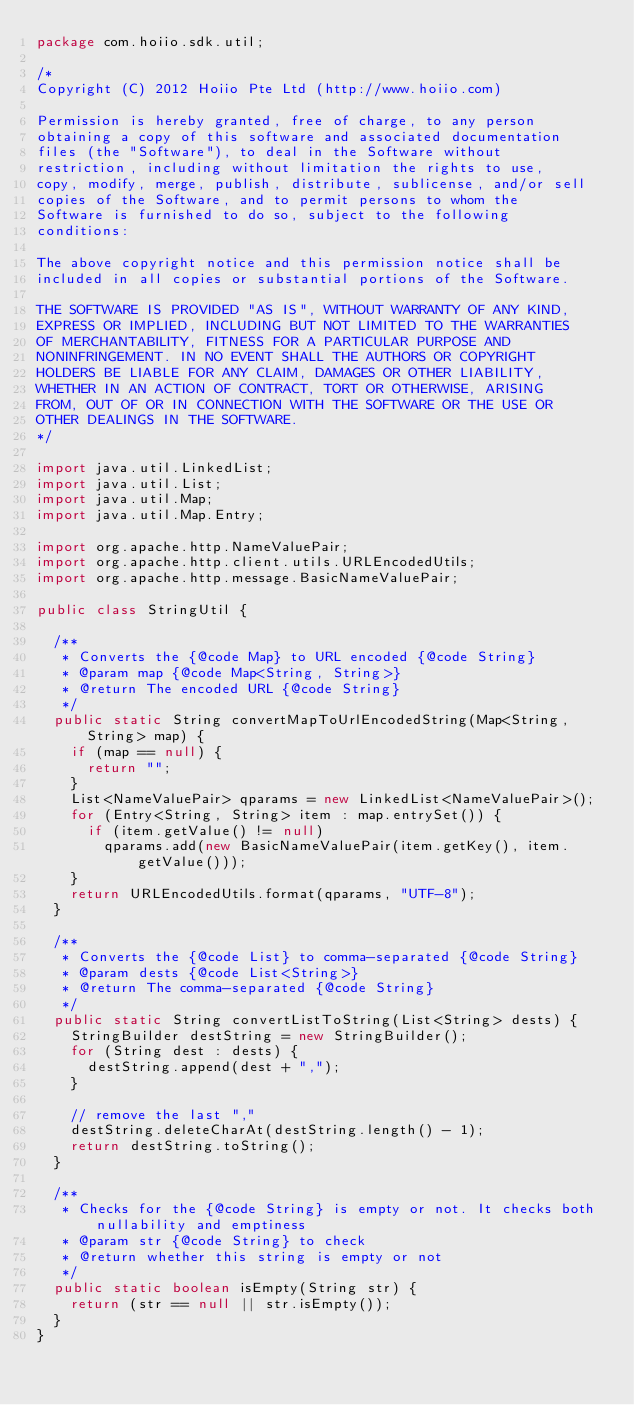Convert code to text. <code><loc_0><loc_0><loc_500><loc_500><_Java_>package com.hoiio.sdk.util;

/*
Copyright (C) 2012 Hoiio Pte Ltd (http://www.hoiio.com)

Permission is hereby granted, free of charge, to any person
obtaining a copy of this software and associated documentation
files (the "Software"), to deal in the Software without
restriction, including without limitation the rights to use,
copy, modify, merge, publish, distribute, sublicense, and/or sell
copies of the Software, and to permit persons to whom the
Software is furnished to do so, subject to the following
conditions:

The above copyright notice and this permission notice shall be
included in all copies or substantial portions of the Software.

THE SOFTWARE IS PROVIDED "AS IS", WITHOUT WARRANTY OF ANY KIND,
EXPRESS OR IMPLIED, INCLUDING BUT NOT LIMITED TO THE WARRANTIES
OF MERCHANTABILITY, FITNESS FOR A PARTICULAR PURPOSE AND
NONINFRINGEMENT. IN NO EVENT SHALL THE AUTHORS OR COPYRIGHT
HOLDERS BE LIABLE FOR ANY CLAIM, DAMAGES OR OTHER LIABILITY,
WHETHER IN AN ACTION OF CONTRACT, TORT OR OTHERWISE, ARISING
FROM, OUT OF OR IN CONNECTION WITH THE SOFTWARE OR THE USE OR
OTHER DEALINGS IN THE SOFTWARE.
*/

import java.util.LinkedList;
import java.util.List;
import java.util.Map;
import java.util.Map.Entry;

import org.apache.http.NameValuePair;
import org.apache.http.client.utils.URLEncodedUtils;
import org.apache.http.message.BasicNameValuePair;

public class StringUtil {
	
	/**
	 * Converts the {@code Map} to URL encoded {@code String}
	 * @param map {@code Map<String, String>}
	 * @return The encoded URL {@code String}
	 */
	public static String convertMapToUrlEncodedString(Map<String, String> map) {
		if (map == null) {
			return "";
		}
		List<NameValuePair> qparams = new LinkedList<NameValuePair>();
		for (Entry<String, String> item : map.entrySet()) {
			if (item.getValue() != null)
				qparams.add(new BasicNameValuePair(item.getKey(), item.getValue()));
		}
		return URLEncodedUtils.format(qparams, "UTF-8");
	}
	
	/**
	 * Converts the {@code List} to comma-separated {@code String}
	 * @param dests {@code List<String>}
	 * @return The comma-separated {@code String}
	 */
	public static String convertListToString(List<String> dests) {
		StringBuilder destString = new StringBuilder();
		for (String dest : dests) {
			destString.append(dest + ",");
		}
		
		// remove the last ","
		destString.deleteCharAt(destString.length() - 1);
		return destString.toString();
	}
	
	/**
	 * Checks for the {@code String} is empty or not. It checks both nullability and emptiness
	 * @param str {@code String} to check
	 * @return whether this string is empty or not
	 */
	public static boolean isEmpty(String str) {
		return (str == null || str.isEmpty());
	}
}
</code> 